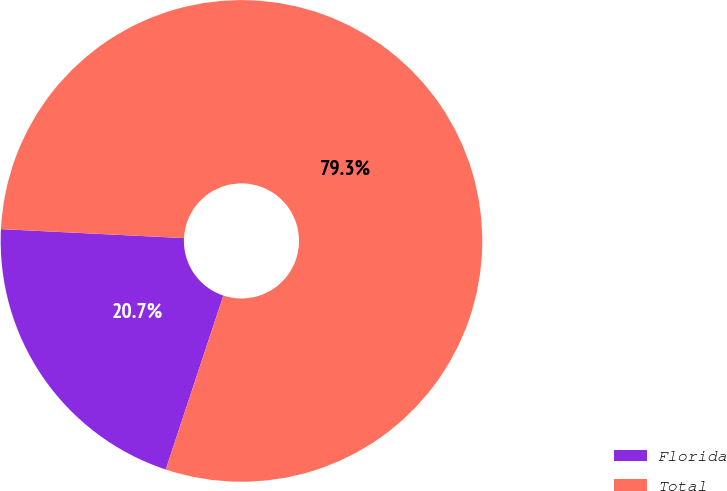Convert chart to OTSL. <chart><loc_0><loc_0><loc_500><loc_500><pie_chart><fcel>Florida<fcel>Total<nl><fcel>20.69%<fcel>79.31%<nl></chart> 